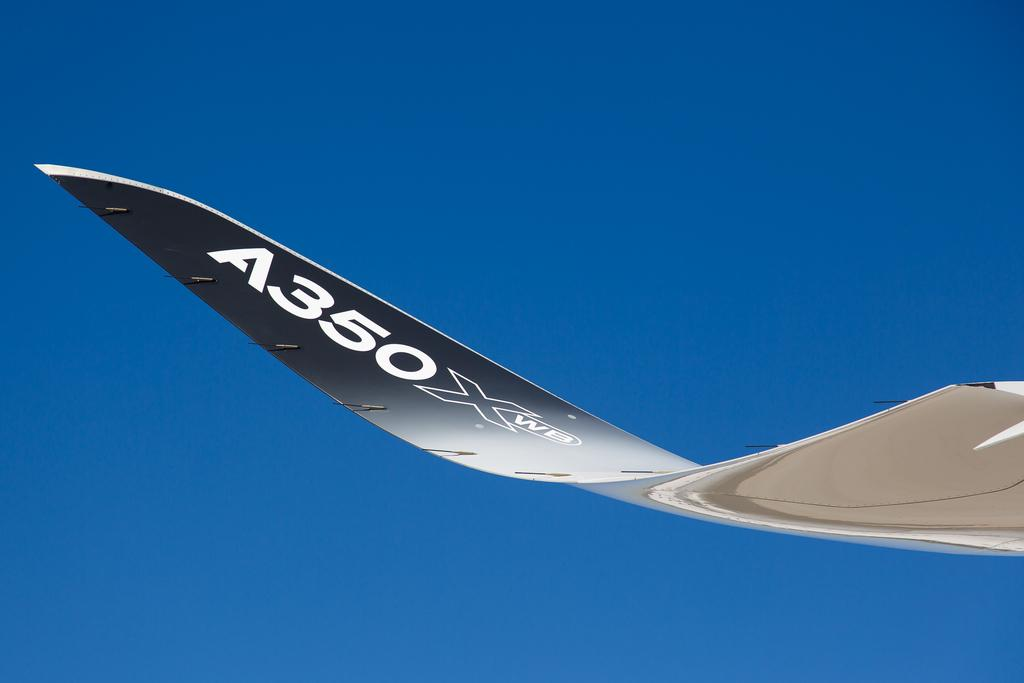<image>
Describe the image concisely. A plane that says A350xwb on the tail end of it. 